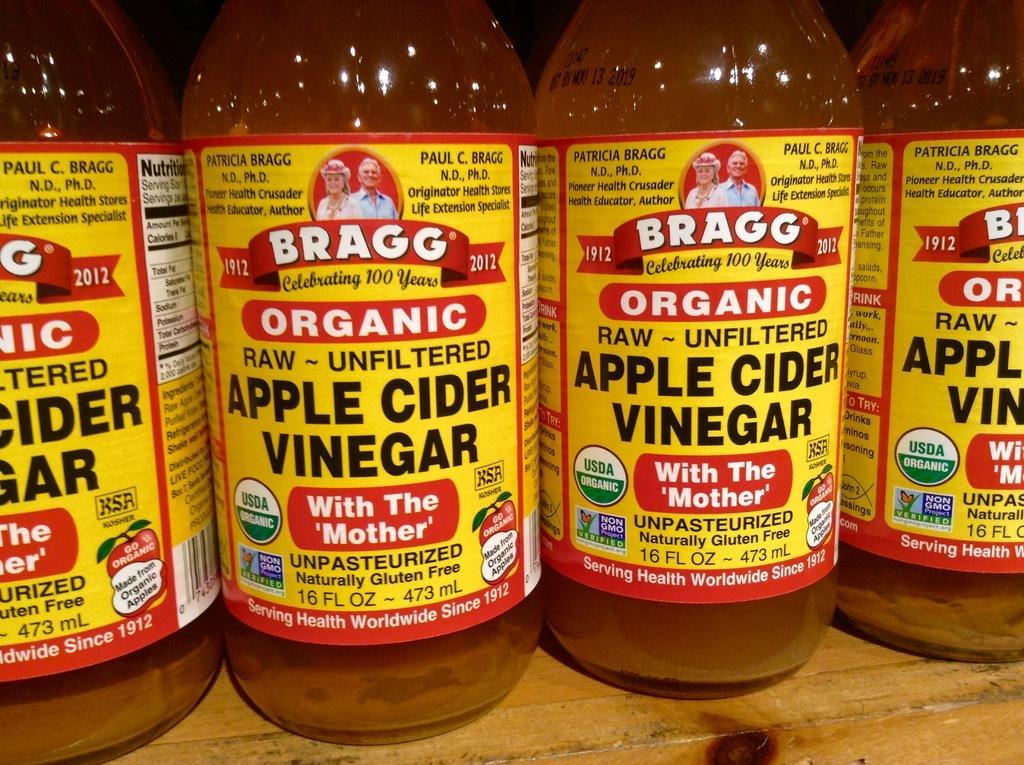In one or two sentences, can you explain what this image depicts? In the image we can see four bottles kept on the wooden surface and there is a label on the bottles. 